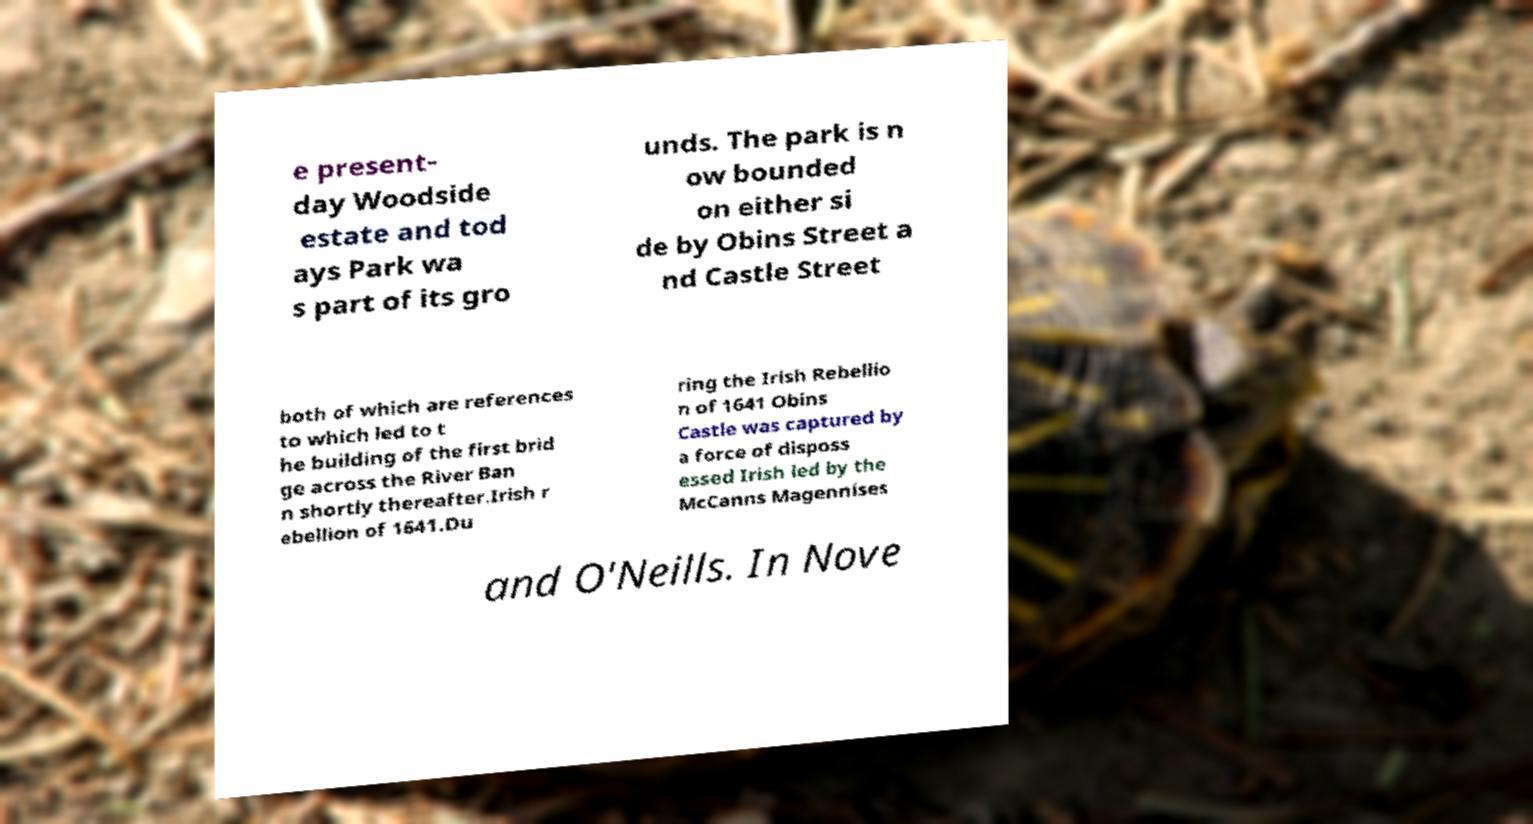What messages or text are displayed in this image? I need them in a readable, typed format. e present- day Woodside estate and tod ays Park wa s part of its gro unds. The park is n ow bounded on either si de by Obins Street a nd Castle Street both of which are references to which led to t he building of the first brid ge across the River Ban n shortly thereafter.Irish r ebellion of 1641.Du ring the Irish Rebellio n of 1641 Obins Castle was captured by a force of disposs essed Irish led by the McCanns Magennises and O'Neills. In Nove 